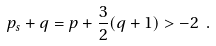Convert formula to latex. <formula><loc_0><loc_0><loc_500><loc_500>p _ { s } + q = p + \frac { 3 } { 2 } ( q + 1 ) > - 2 \ .</formula> 